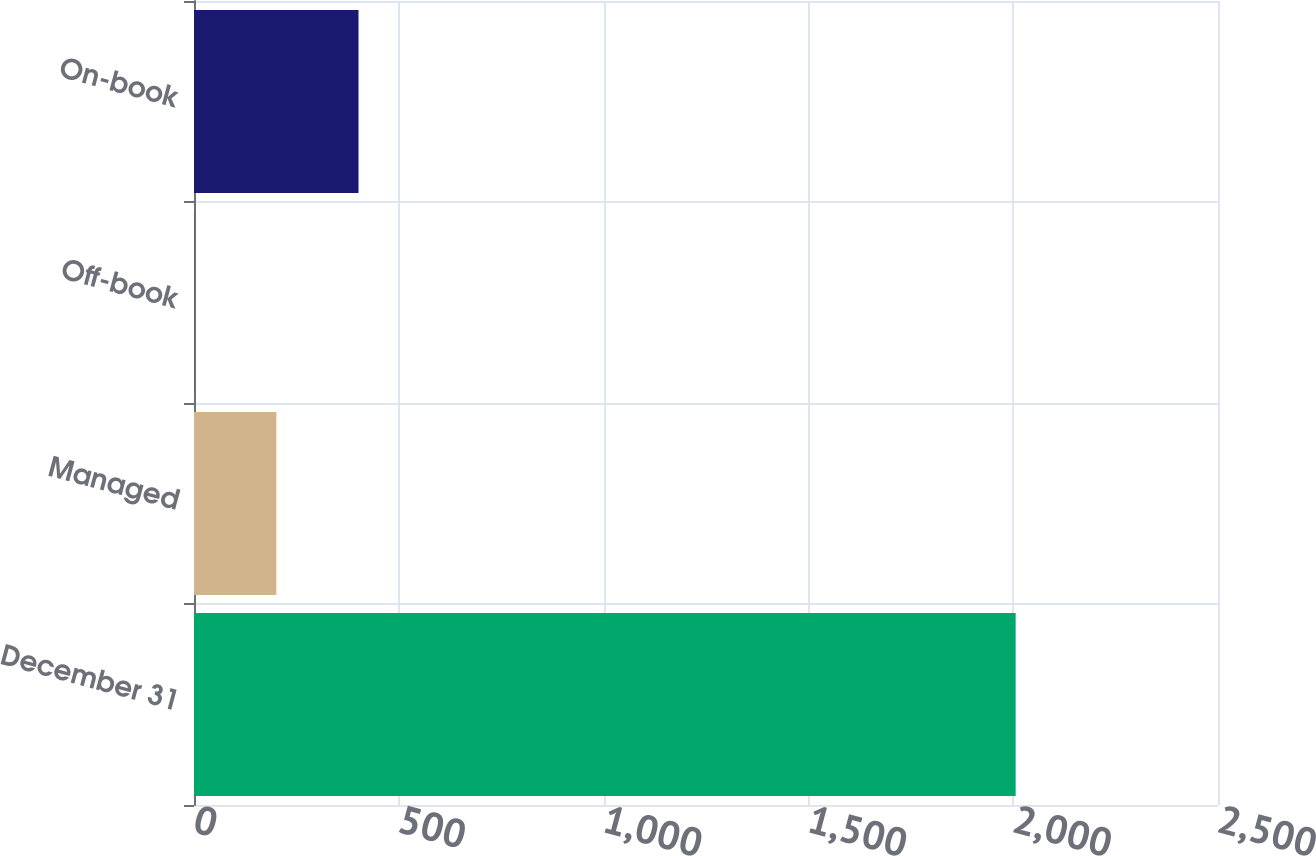Convert chart. <chart><loc_0><loc_0><loc_500><loc_500><bar_chart><fcel>December 31<fcel>Managed<fcel>Off-book<fcel>On-book<nl><fcel>2006<fcel>201.07<fcel>0.52<fcel>401.62<nl></chart> 